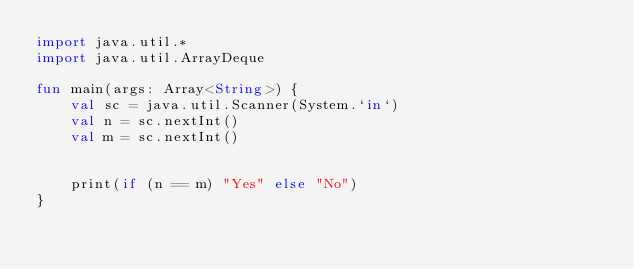Convert code to text. <code><loc_0><loc_0><loc_500><loc_500><_Kotlin_>import java.util.*
import java.util.ArrayDeque

fun main(args: Array<String>) {
    val sc = java.util.Scanner(System.`in`)
    val n = sc.nextInt()
    val m = sc.nextInt()


    print(if (n == m) "Yes" else "No")
}
</code> 